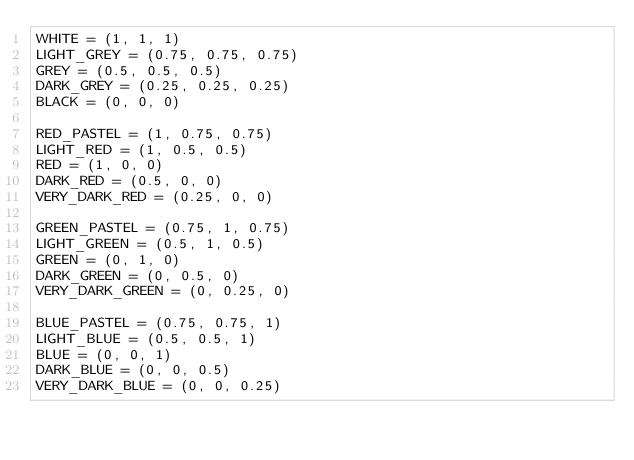Convert code to text. <code><loc_0><loc_0><loc_500><loc_500><_Python_>WHITE = (1, 1, 1)
LIGHT_GREY = (0.75, 0.75, 0.75)
GREY = (0.5, 0.5, 0.5)
DARK_GREY = (0.25, 0.25, 0.25)
BLACK = (0, 0, 0)

RED_PASTEL = (1, 0.75, 0.75)
LIGHT_RED = (1, 0.5, 0.5)
RED = (1, 0, 0)
DARK_RED = (0.5, 0, 0)
VERY_DARK_RED = (0.25, 0, 0)

GREEN_PASTEL = (0.75, 1, 0.75)
LIGHT_GREEN = (0.5, 1, 0.5)
GREEN = (0, 1, 0)
DARK_GREEN = (0, 0.5, 0)
VERY_DARK_GREEN = (0, 0.25, 0)

BLUE_PASTEL = (0.75, 0.75, 1)
LIGHT_BLUE = (0.5, 0.5, 1)
BLUE = (0, 0, 1)
DARK_BLUE = (0, 0, 0.5)
VERY_DARK_BLUE = (0, 0, 0.25)
</code> 